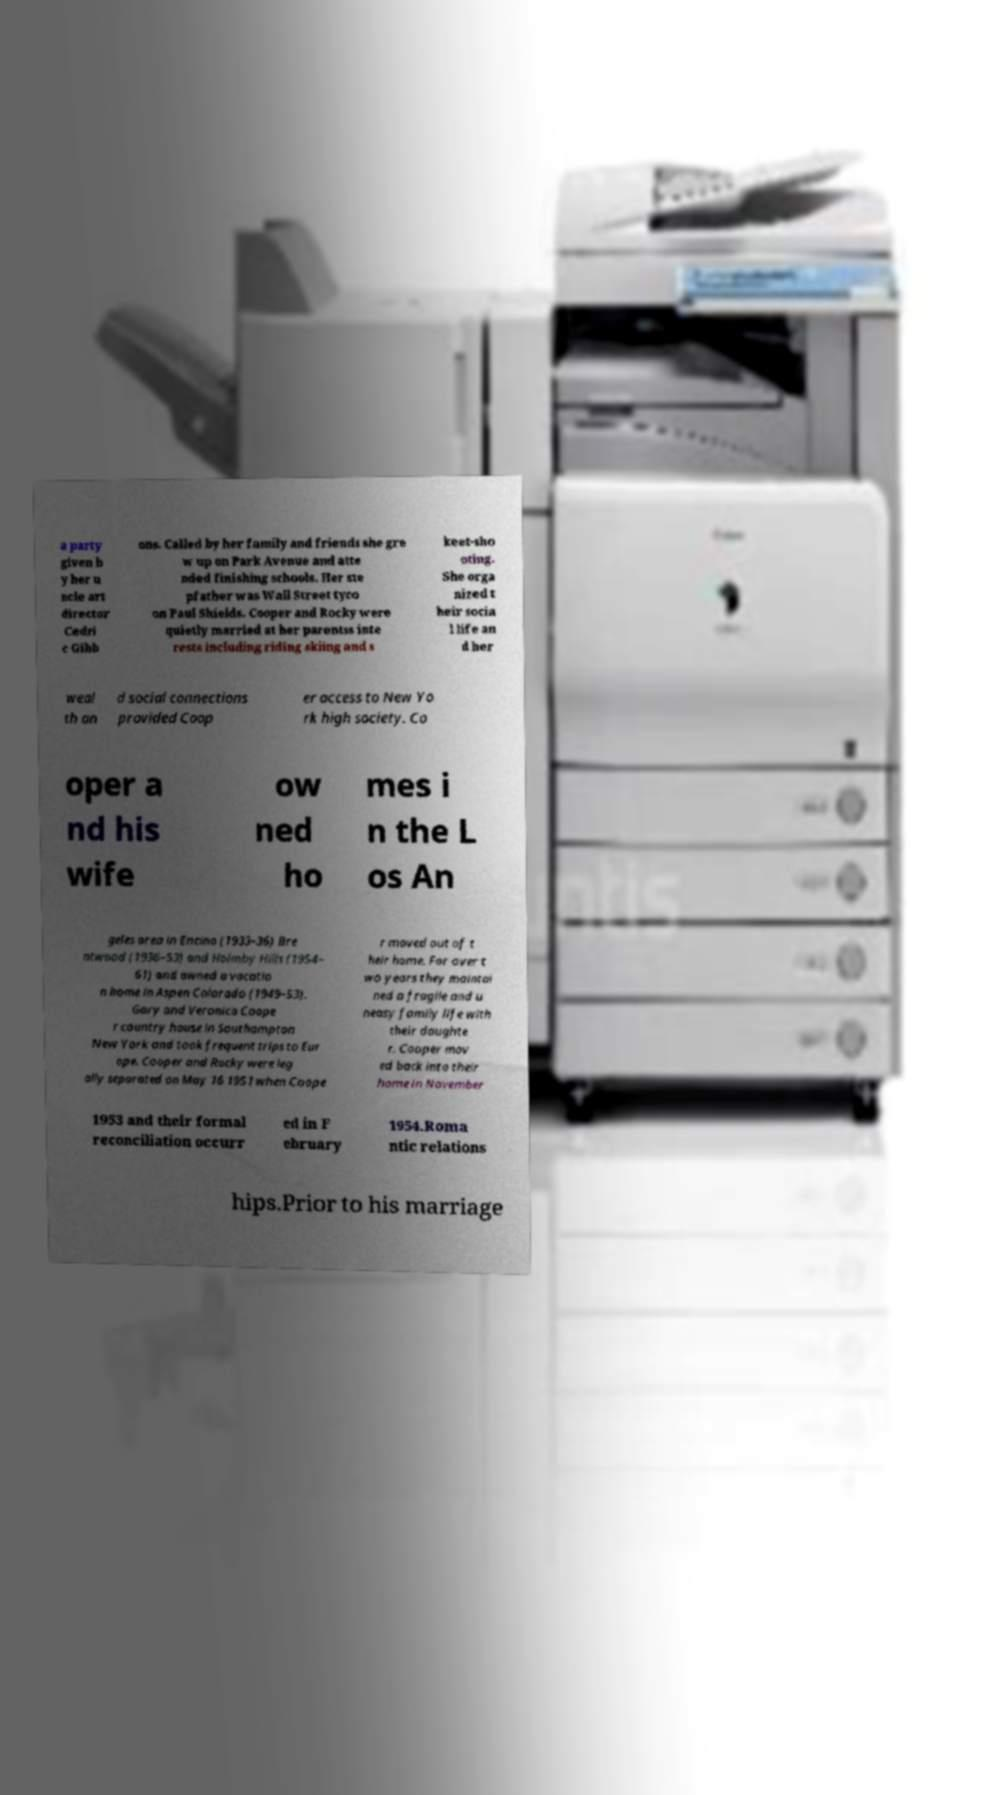Could you assist in decoding the text presented in this image and type it out clearly? a party given b y her u ncle art director Cedri c Gibb ons. Called by her family and friends she gre w up on Park Avenue and atte nded finishing schools. Her ste pfather was Wall Street tyco on Paul Shields. Cooper and Rocky were quietly married at her parentss inte rests including riding skiing and s keet-sho oting. She orga nized t heir socia l life an d her weal th an d social connections provided Coop er access to New Yo rk high society. Co oper a nd his wife ow ned ho mes i n the L os An geles area in Encino (1933–36) Bre ntwood (1936–53) and Holmby Hills (1954– 61) and owned a vacatio n home in Aspen Colorado (1949–53). Gary and Veronica Coope r country house in Southampton New York and took frequent trips to Eur ope. Cooper and Rocky were leg ally separated on May 16 1951 when Coope r moved out of t heir home. For over t wo years they maintai ned a fragile and u neasy family life with their daughte r. Cooper mov ed back into their home in November 1953 and their formal reconciliation occurr ed in F ebruary 1954.Roma ntic relations hips.Prior to his marriage 